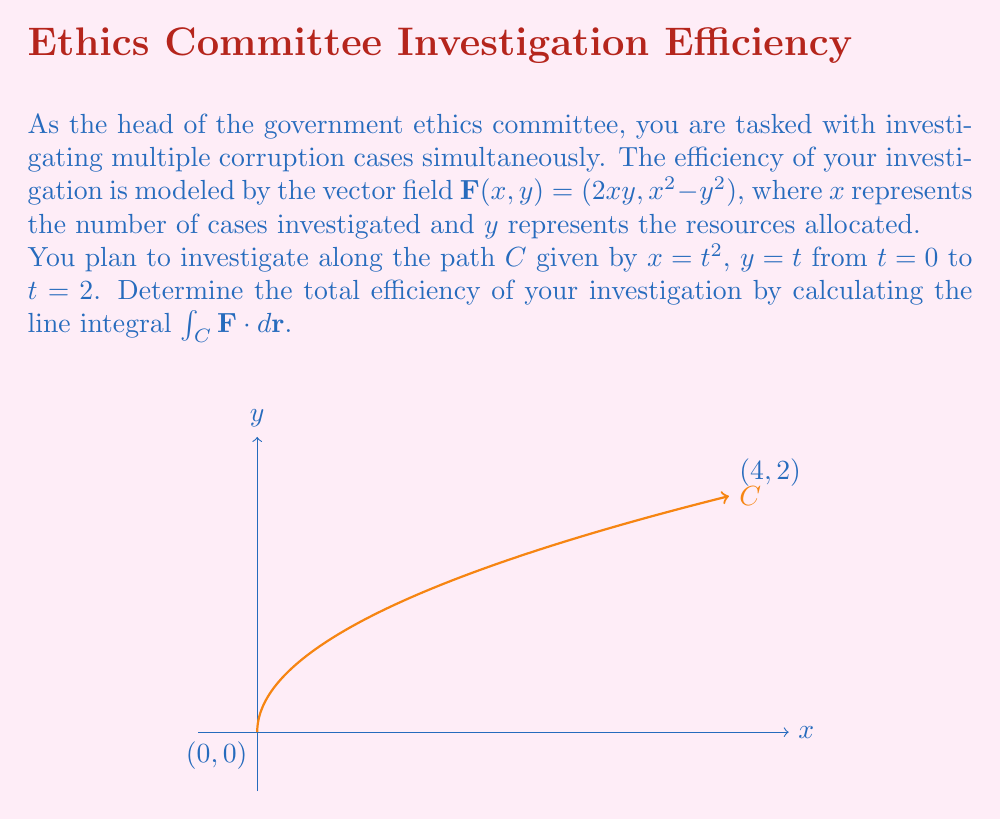What is the answer to this math problem? To solve this problem, we'll follow these steps:

1) First, we need to parametrize the path $C$. We're given:
   $x = t^2$, $y = t$, $0 \leq t \leq 2$

2) We need to find $dx$ and $dy$:
   $dx = 2t dt$
   $dy = dt$

3) The vector field is $\mathbf{F}(x,y) = (2xy, x^2 - y^2)$. We need to substitute our parametrization:
   $\mathbf{F}(t^2, t) = (2t^2t, (t^2)^2 - t^2) = (2t^3, t^4 - t^2)$

4) Now we can set up the line integral:
   $$\int_C \mathbf{F} \cdot d\mathbf{r} = \int_0^2 (2t^3, t^4 - t^2) \cdot (2t, 1) dt$$

5) Simplify the dot product:
   $$\int_0^2 (4t^4 + t^4 - t^2) dt = \int_0^2 (5t^4 - t^2) dt$$

6) Integrate:
   $$\left[\frac{5t^5}{5} - \frac{t^3}{3}\right]_0^2$$

7) Evaluate the bounds:
   $$(\frac{5(2^5)}{5} - \frac{2^3}{3}) - (0 - 0) = 32 - \frac{8}{3} = \frac{88}{3}$$

Thus, the total efficiency of your investigation along this path is $\frac{88}{3}$.
Answer: $\frac{88}{3}$ 